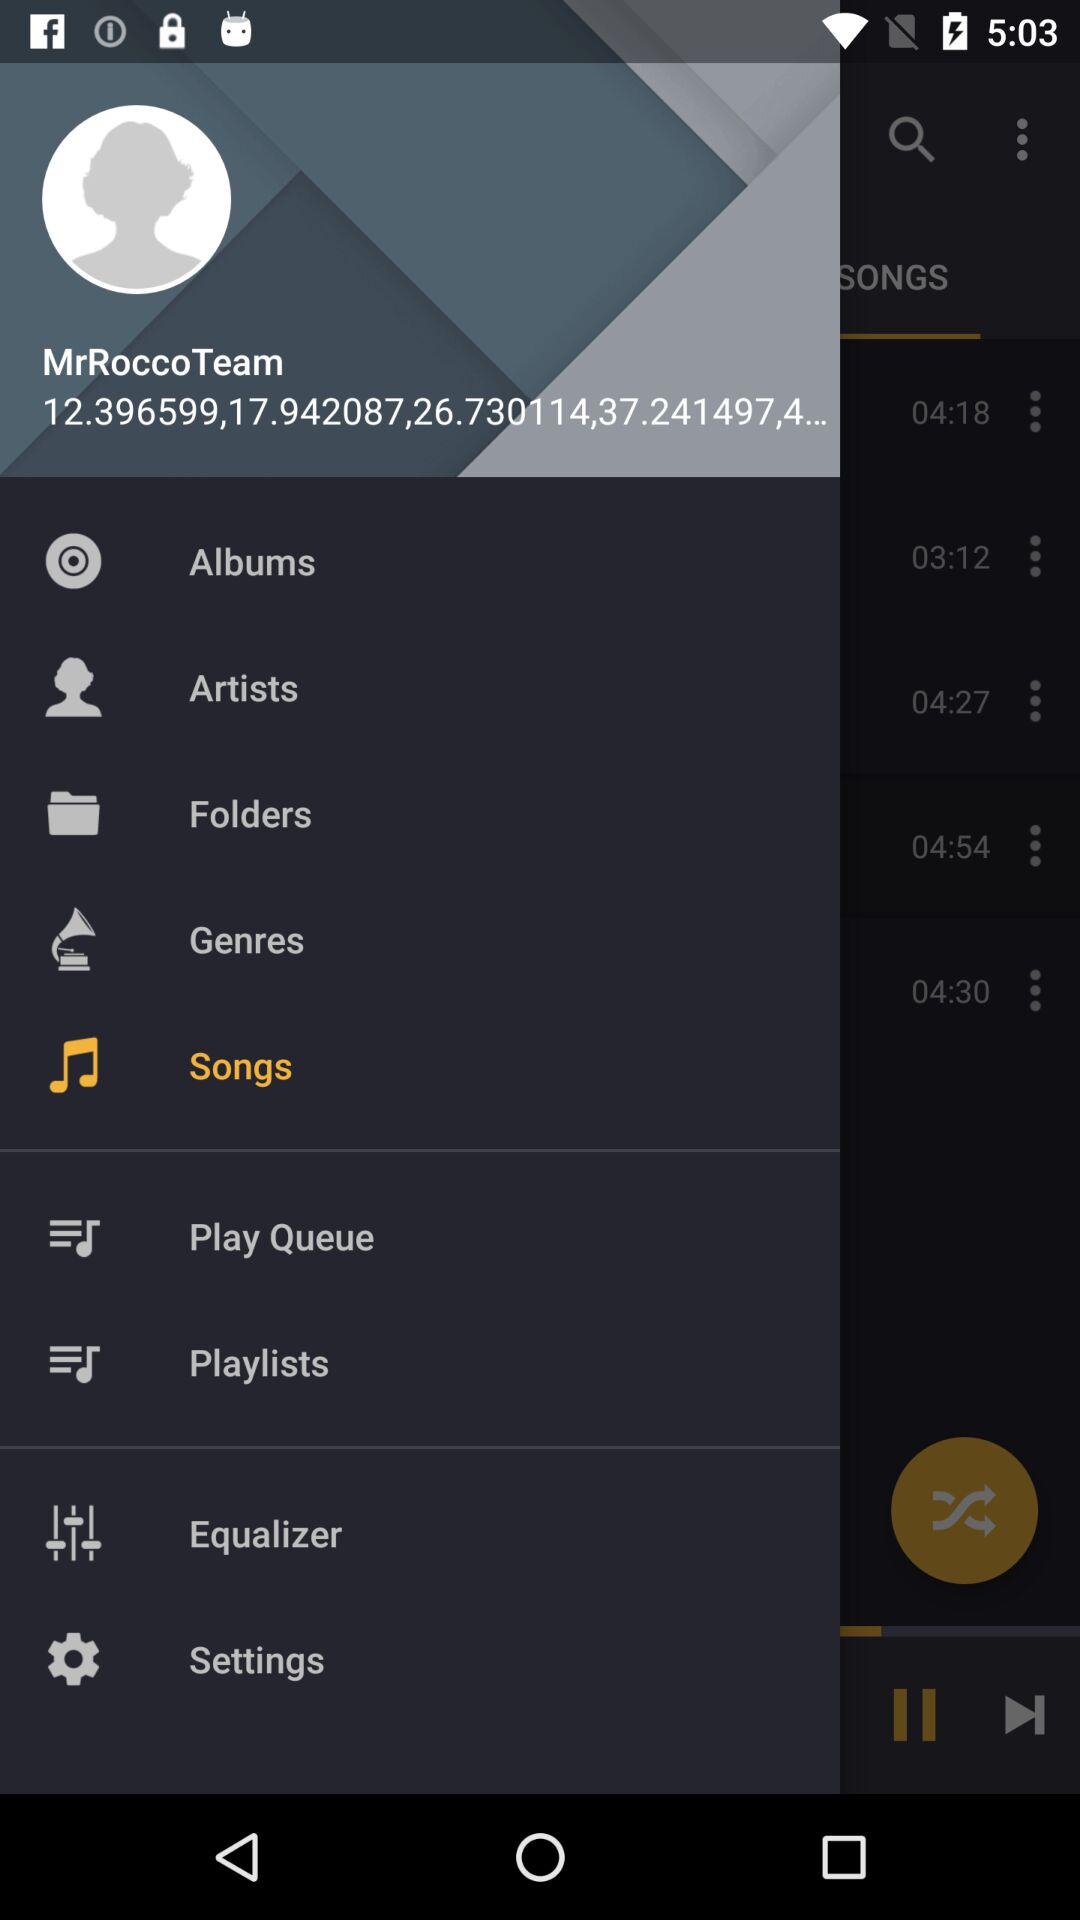Who is listed as an artist?
When the provided information is insufficient, respond with <no answer>. <no answer> 